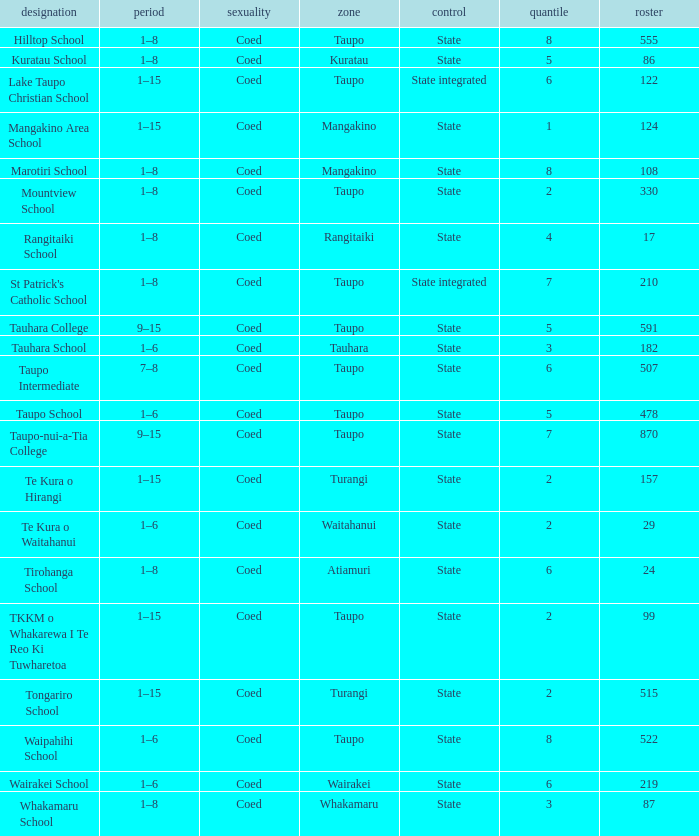What is the Whakamaru school's authority? State. 